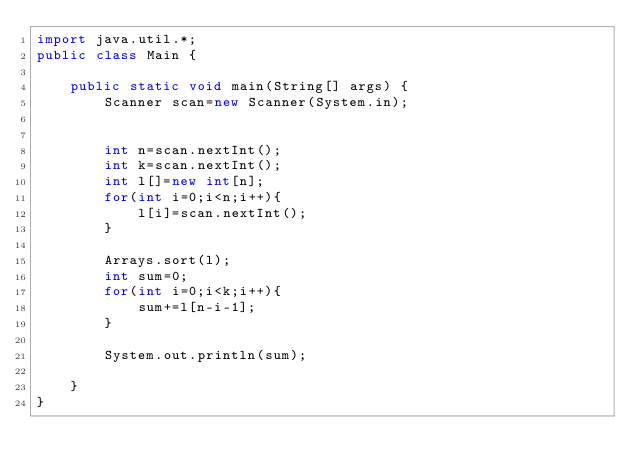<code> <loc_0><loc_0><loc_500><loc_500><_Java_>import java.util.*;
public class Main {

    public static void main(String[] args) {
        Scanner scan=new Scanner(System.in);


        int n=scan.nextInt();
        int k=scan.nextInt();
        int l[]=new int[n];
        for(int i=0;i<n;i++){
            l[i]=scan.nextInt();
        }

        Arrays.sort(l);
        int sum=0;
        for(int i=0;i<k;i++){
            sum+=l[n-i-1];
        }

        System.out.println(sum);

    }
}</code> 